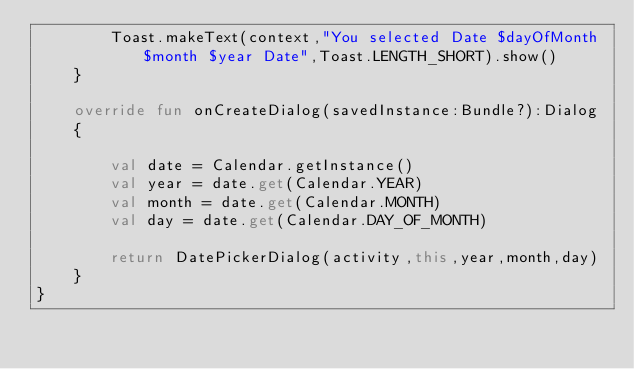Convert code to text. <code><loc_0><loc_0><loc_500><loc_500><_Kotlin_>        Toast.makeText(context,"You selected Date $dayOfMonth $month $year Date",Toast.LENGTH_SHORT).show()
    }

    override fun onCreateDialog(savedInstance:Bundle?):Dialog
    {

        val date = Calendar.getInstance()
        val year = date.get(Calendar.YEAR)
        val month = date.get(Calendar.MONTH)
        val day = date.get(Calendar.DAY_OF_MONTH)

        return DatePickerDialog(activity,this,year,month,day)
    }
}</code> 